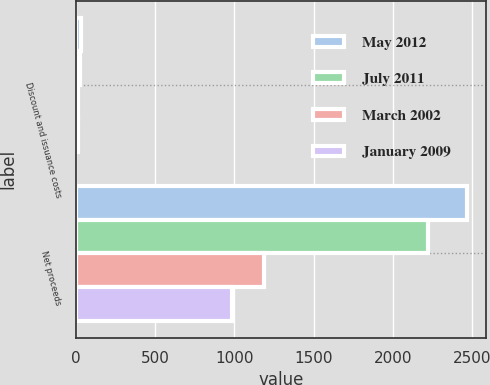<chart> <loc_0><loc_0><loc_500><loc_500><stacked_bar_chart><ecel><fcel>Discount and issuance costs<fcel>Net proceeds<nl><fcel>May 2012<fcel>35<fcel>2465<nl><fcel>July 2011<fcel>29<fcel>2221<nl><fcel>March 2002<fcel>13<fcel>1187<nl><fcel>January 2009<fcel>14<fcel>986<nl></chart> 